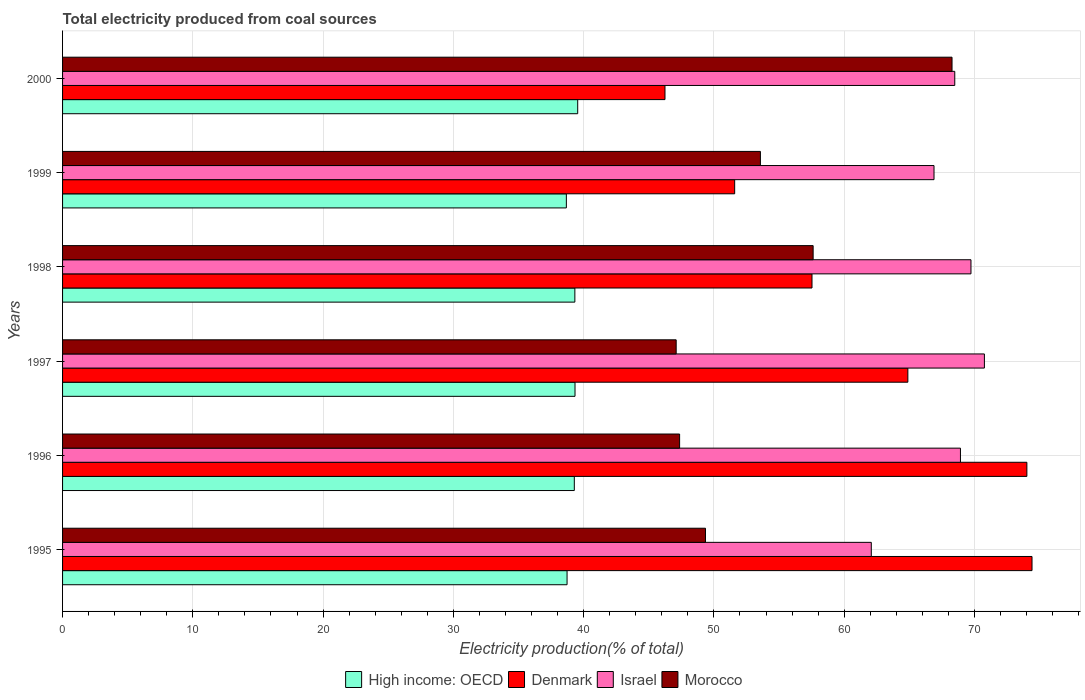How many different coloured bars are there?
Your response must be concise. 4. How many groups of bars are there?
Keep it short and to the point. 6. Are the number of bars per tick equal to the number of legend labels?
Your answer should be very brief. Yes. Are the number of bars on each tick of the Y-axis equal?
Your answer should be compact. Yes. How many bars are there on the 2nd tick from the bottom?
Keep it short and to the point. 4. What is the label of the 2nd group of bars from the top?
Provide a succinct answer. 1999. What is the total electricity produced in Denmark in 1998?
Your answer should be compact. 57.53. Across all years, what is the maximum total electricity produced in Denmark?
Provide a short and direct response. 74.42. Across all years, what is the minimum total electricity produced in Morocco?
Give a very brief answer. 47.11. What is the total total electricity produced in Morocco in the graph?
Offer a very short reply. 323.3. What is the difference between the total electricity produced in High income: OECD in 1996 and that in 1997?
Your response must be concise. -0.05. What is the difference between the total electricity produced in Denmark in 1997 and the total electricity produced in Morocco in 1998?
Keep it short and to the point. 7.27. What is the average total electricity produced in High income: OECD per year?
Provide a succinct answer. 39.15. In the year 1997, what is the difference between the total electricity produced in Denmark and total electricity produced in Morocco?
Provide a succinct answer. 17.78. What is the ratio of the total electricity produced in Israel in 1995 to that in 2000?
Provide a succinct answer. 0.91. What is the difference between the highest and the second highest total electricity produced in High income: OECD?
Your answer should be compact. 0.21. What is the difference between the highest and the lowest total electricity produced in High income: OECD?
Make the answer very short. 0.87. Is the sum of the total electricity produced in Morocco in 1997 and 1998 greater than the maximum total electricity produced in High income: OECD across all years?
Keep it short and to the point. Yes. What does the 4th bar from the top in 1997 represents?
Give a very brief answer. High income: OECD. What does the 3rd bar from the bottom in 1996 represents?
Ensure brevity in your answer.  Israel. Is it the case that in every year, the sum of the total electricity produced in Morocco and total electricity produced in Israel is greater than the total electricity produced in High income: OECD?
Provide a succinct answer. Yes. Are all the bars in the graph horizontal?
Your answer should be very brief. Yes. How many years are there in the graph?
Offer a very short reply. 6. What is the difference between two consecutive major ticks on the X-axis?
Your answer should be very brief. 10. Does the graph contain any zero values?
Your answer should be very brief. No. Where does the legend appear in the graph?
Offer a terse response. Bottom center. How are the legend labels stacked?
Your answer should be very brief. Horizontal. What is the title of the graph?
Offer a terse response. Total electricity produced from coal sources. What is the label or title of the Y-axis?
Keep it short and to the point. Years. What is the Electricity production(% of total) in High income: OECD in 1995?
Offer a very short reply. 38.73. What is the Electricity production(% of total) of Denmark in 1995?
Provide a short and direct response. 74.42. What is the Electricity production(% of total) in Israel in 1995?
Keep it short and to the point. 62.08. What is the Electricity production(% of total) of Morocco in 1995?
Offer a very short reply. 49.35. What is the Electricity production(% of total) in High income: OECD in 1996?
Your response must be concise. 39.28. What is the Electricity production(% of total) of Denmark in 1996?
Offer a very short reply. 74.03. What is the Electricity production(% of total) of Israel in 1996?
Ensure brevity in your answer.  68.93. What is the Electricity production(% of total) in Morocco in 1996?
Your response must be concise. 47.37. What is the Electricity production(% of total) in High income: OECD in 1997?
Your answer should be very brief. 39.34. What is the Electricity production(% of total) in Denmark in 1997?
Your answer should be compact. 64.89. What is the Electricity production(% of total) in Israel in 1997?
Provide a succinct answer. 70.77. What is the Electricity production(% of total) of Morocco in 1997?
Ensure brevity in your answer.  47.11. What is the Electricity production(% of total) in High income: OECD in 1998?
Ensure brevity in your answer.  39.33. What is the Electricity production(% of total) in Denmark in 1998?
Your answer should be very brief. 57.53. What is the Electricity production(% of total) in Israel in 1998?
Offer a very short reply. 69.74. What is the Electricity production(% of total) of Morocco in 1998?
Make the answer very short. 57.62. What is the Electricity production(% of total) of High income: OECD in 1999?
Give a very brief answer. 38.67. What is the Electricity production(% of total) in Denmark in 1999?
Your response must be concise. 51.6. What is the Electricity production(% of total) of Israel in 1999?
Your answer should be very brief. 66.9. What is the Electricity production(% of total) in Morocco in 1999?
Give a very brief answer. 53.57. What is the Electricity production(% of total) in High income: OECD in 2000?
Give a very brief answer. 39.55. What is the Electricity production(% of total) in Denmark in 2000?
Offer a very short reply. 46.25. What is the Electricity production(% of total) of Israel in 2000?
Keep it short and to the point. 68.49. What is the Electricity production(% of total) of Morocco in 2000?
Make the answer very short. 68.28. Across all years, what is the maximum Electricity production(% of total) in High income: OECD?
Ensure brevity in your answer.  39.55. Across all years, what is the maximum Electricity production(% of total) of Denmark?
Ensure brevity in your answer.  74.42. Across all years, what is the maximum Electricity production(% of total) of Israel?
Your response must be concise. 70.77. Across all years, what is the maximum Electricity production(% of total) of Morocco?
Your answer should be very brief. 68.28. Across all years, what is the minimum Electricity production(% of total) in High income: OECD?
Give a very brief answer. 38.67. Across all years, what is the minimum Electricity production(% of total) of Denmark?
Give a very brief answer. 46.25. Across all years, what is the minimum Electricity production(% of total) in Israel?
Provide a succinct answer. 62.08. Across all years, what is the minimum Electricity production(% of total) in Morocco?
Your answer should be compact. 47.11. What is the total Electricity production(% of total) in High income: OECD in the graph?
Your answer should be very brief. 234.9. What is the total Electricity production(% of total) of Denmark in the graph?
Offer a very short reply. 368.71. What is the total Electricity production(% of total) of Israel in the graph?
Your response must be concise. 406.9. What is the total Electricity production(% of total) of Morocco in the graph?
Your answer should be very brief. 323.3. What is the difference between the Electricity production(% of total) of High income: OECD in 1995 and that in 1996?
Provide a succinct answer. -0.56. What is the difference between the Electricity production(% of total) of Denmark in 1995 and that in 1996?
Offer a terse response. 0.4. What is the difference between the Electricity production(% of total) of Israel in 1995 and that in 1996?
Give a very brief answer. -6.84. What is the difference between the Electricity production(% of total) in Morocco in 1995 and that in 1996?
Keep it short and to the point. 1.99. What is the difference between the Electricity production(% of total) in High income: OECD in 1995 and that in 1997?
Offer a very short reply. -0.61. What is the difference between the Electricity production(% of total) of Denmark in 1995 and that in 1997?
Provide a short and direct response. 9.53. What is the difference between the Electricity production(% of total) in Israel in 1995 and that in 1997?
Your answer should be compact. -8.68. What is the difference between the Electricity production(% of total) of Morocco in 1995 and that in 1997?
Provide a short and direct response. 2.25. What is the difference between the Electricity production(% of total) of High income: OECD in 1995 and that in 1998?
Offer a terse response. -0.6. What is the difference between the Electricity production(% of total) of Denmark in 1995 and that in 1998?
Your answer should be compact. 16.89. What is the difference between the Electricity production(% of total) of Israel in 1995 and that in 1998?
Provide a succinct answer. -7.65. What is the difference between the Electricity production(% of total) in Morocco in 1995 and that in 1998?
Provide a short and direct response. -8.26. What is the difference between the Electricity production(% of total) in High income: OECD in 1995 and that in 1999?
Offer a very short reply. 0.05. What is the difference between the Electricity production(% of total) in Denmark in 1995 and that in 1999?
Your response must be concise. 22.83. What is the difference between the Electricity production(% of total) of Israel in 1995 and that in 1999?
Ensure brevity in your answer.  -4.81. What is the difference between the Electricity production(% of total) in Morocco in 1995 and that in 1999?
Offer a very short reply. -4.22. What is the difference between the Electricity production(% of total) of High income: OECD in 1995 and that in 2000?
Make the answer very short. -0.82. What is the difference between the Electricity production(% of total) in Denmark in 1995 and that in 2000?
Provide a succinct answer. 28.18. What is the difference between the Electricity production(% of total) of Israel in 1995 and that in 2000?
Your answer should be very brief. -6.41. What is the difference between the Electricity production(% of total) of Morocco in 1995 and that in 2000?
Your answer should be compact. -18.93. What is the difference between the Electricity production(% of total) of High income: OECD in 1996 and that in 1997?
Make the answer very short. -0.05. What is the difference between the Electricity production(% of total) in Denmark in 1996 and that in 1997?
Your answer should be very brief. 9.14. What is the difference between the Electricity production(% of total) of Israel in 1996 and that in 1997?
Provide a short and direct response. -1.84. What is the difference between the Electricity production(% of total) in Morocco in 1996 and that in 1997?
Your response must be concise. 0.26. What is the difference between the Electricity production(% of total) of High income: OECD in 1996 and that in 1998?
Ensure brevity in your answer.  -0.04. What is the difference between the Electricity production(% of total) in Denmark in 1996 and that in 1998?
Offer a very short reply. 16.5. What is the difference between the Electricity production(% of total) of Israel in 1996 and that in 1998?
Your response must be concise. -0.81. What is the difference between the Electricity production(% of total) of Morocco in 1996 and that in 1998?
Your response must be concise. -10.25. What is the difference between the Electricity production(% of total) in High income: OECD in 1996 and that in 1999?
Give a very brief answer. 0.61. What is the difference between the Electricity production(% of total) in Denmark in 1996 and that in 1999?
Offer a very short reply. 22.43. What is the difference between the Electricity production(% of total) in Israel in 1996 and that in 1999?
Your answer should be very brief. 2.03. What is the difference between the Electricity production(% of total) in Morocco in 1996 and that in 1999?
Offer a very short reply. -6.2. What is the difference between the Electricity production(% of total) of High income: OECD in 1996 and that in 2000?
Offer a terse response. -0.26. What is the difference between the Electricity production(% of total) in Denmark in 1996 and that in 2000?
Your response must be concise. 27.78. What is the difference between the Electricity production(% of total) in Israel in 1996 and that in 2000?
Offer a terse response. 0.44. What is the difference between the Electricity production(% of total) in Morocco in 1996 and that in 2000?
Your response must be concise. -20.91. What is the difference between the Electricity production(% of total) of High income: OECD in 1997 and that in 1998?
Make the answer very short. 0.01. What is the difference between the Electricity production(% of total) in Denmark in 1997 and that in 1998?
Offer a very short reply. 7.36. What is the difference between the Electricity production(% of total) of Israel in 1997 and that in 1998?
Give a very brief answer. 1.03. What is the difference between the Electricity production(% of total) in Morocco in 1997 and that in 1998?
Your answer should be very brief. -10.51. What is the difference between the Electricity production(% of total) of High income: OECD in 1997 and that in 1999?
Provide a short and direct response. 0.67. What is the difference between the Electricity production(% of total) in Denmark in 1997 and that in 1999?
Your answer should be compact. 13.29. What is the difference between the Electricity production(% of total) in Israel in 1997 and that in 1999?
Give a very brief answer. 3.87. What is the difference between the Electricity production(% of total) in Morocco in 1997 and that in 1999?
Provide a succinct answer. -6.47. What is the difference between the Electricity production(% of total) in High income: OECD in 1997 and that in 2000?
Your response must be concise. -0.21. What is the difference between the Electricity production(% of total) in Denmark in 1997 and that in 2000?
Provide a short and direct response. 18.64. What is the difference between the Electricity production(% of total) in Israel in 1997 and that in 2000?
Your response must be concise. 2.28. What is the difference between the Electricity production(% of total) of Morocco in 1997 and that in 2000?
Your response must be concise. -21.18. What is the difference between the Electricity production(% of total) of High income: OECD in 1998 and that in 1999?
Your answer should be compact. 0.65. What is the difference between the Electricity production(% of total) of Denmark in 1998 and that in 1999?
Your answer should be compact. 5.94. What is the difference between the Electricity production(% of total) in Israel in 1998 and that in 1999?
Give a very brief answer. 2.84. What is the difference between the Electricity production(% of total) of Morocco in 1998 and that in 1999?
Your answer should be compact. 4.05. What is the difference between the Electricity production(% of total) of High income: OECD in 1998 and that in 2000?
Offer a terse response. -0.22. What is the difference between the Electricity production(% of total) of Denmark in 1998 and that in 2000?
Keep it short and to the point. 11.29. What is the difference between the Electricity production(% of total) in Israel in 1998 and that in 2000?
Make the answer very short. 1.24. What is the difference between the Electricity production(% of total) of Morocco in 1998 and that in 2000?
Make the answer very short. -10.66. What is the difference between the Electricity production(% of total) of High income: OECD in 1999 and that in 2000?
Provide a succinct answer. -0.87. What is the difference between the Electricity production(% of total) in Denmark in 1999 and that in 2000?
Provide a succinct answer. 5.35. What is the difference between the Electricity production(% of total) of Israel in 1999 and that in 2000?
Offer a terse response. -1.59. What is the difference between the Electricity production(% of total) in Morocco in 1999 and that in 2000?
Offer a very short reply. -14.71. What is the difference between the Electricity production(% of total) of High income: OECD in 1995 and the Electricity production(% of total) of Denmark in 1996?
Give a very brief answer. -35.3. What is the difference between the Electricity production(% of total) in High income: OECD in 1995 and the Electricity production(% of total) in Israel in 1996?
Provide a succinct answer. -30.2. What is the difference between the Electricity production(% of total) of High income: OECD in 1995 and the Electricity production(% of total) of Morocco in 1996?
Keep it short and to the point. -8.64. What is the difference between the Electricity production(% of total) of Denmark in 1995 and the Electricity production(% of total) of Israel in 1996?
Provide a succinct answer. 5.49. What is the difference between the Electricity production(% of total) of Denmark in 1995 and the Electricity production(% of total) of Morocco in 1996?
Provide a short and direct response. 27.05. What is the difference between the Electricity production(% of total) of Israel in 1995 and the Electricity production(% of total) of Morocco in 1996?
Your answer should be compact. 14.72. What is the difference between the Electricity production(% of total) in High income: OECD in 1995 and the Electricity production(% of total) in Denmark in 1997?
Your answer should be very brief. -26.16. What is the difference between the Electricity production(% of total) in High income: OECD in 1995 and the Electricity production(% of total) in Israel in 1997?
Provide a short and direct response. -32.04. What is the difference between the Electricity production(% of total) in High income: OECD in 1995 and the Electricity production(% of total) in Morocco in 1997?
Offer a terse response. -8.38. What is the difference between the Electricity production(% of total) in Denmark in 1995 and the Electricity production(% of total) in Israel in 1997?
Offer a terse response. 3.66. What is the difference between the Electricity production(% of total) of Denmark in 1995 and the Electricity production(% of total) of Morocco in 1997?
Give a very brief answer. 27.32. What is the difference between the Electricity production(% of total) in Israel in 1995 and the Electricity production(% of total) in Morocco in 1997?
Provide a succinct answer. 14.98. What is the difference between the Electricity production(% of total) in High income: OECD in 1995 and the Electricity production(% of total) in Denmark in 1998?
Your answer should be compact. -18.8. What is the difference between the Electricity production(% of total) in High income: OECD in 1995 and the Electricity production(% of total) in Israel in 1998?
Offer a terse response. -31.01. What is the difference between the Electricity production(% of total) in High income: OECD in 1995 and the Electricity production(% of total) in Morocco in 1998?
Offer a very short reply. -18.89. What is the difference between the Electricity production(% of total) in Denmark in 1995 and the Electricity production(% of total) in Israel in 1998?
Give a very brief answer. 4.69. What is the difference between the Electricity production(% of total) of Denmark in 1995 and the Electricity production(% of total) of Morocco in 1998?
Your response must be concise. 16.8. What is the difference between the Electricity production(% of total) of Israel in 1995 and the Electricity production(% of total) of Morocco in 1998?
Your response must be concise. 4.47. What is the difference between the Electricity production(% of total) of High income: OECD in 1995 and the Electricity production(% of total) of Denmark in 1999?
Give a very brief answer. -12.87. What is the difference between the Electricity production(% of total) in High income: OECD in 1995 and the Electricity production(% of total) in Israel in 1999?
Your answer should be compact. -28.17. What is the difference between the Electricity production(% of total) in High income: OECD in 1995 and the Electricity production(% of total) in Morocco in 1999?
Give a very brief answer. -14.84. What is the difference between the Electricity production(% of total) in Denmark in 1995 and the Electricity production(% of total) in Israel in 1999?
Make the answer very short. 7.52. What is the difference between the Electricity production(% of total) of Denmark in 1995 and the Electricity production(% of total) of Morocco in 1999?
Offer a terse response. 20.85. What is the difference between the Electricity production(% of total) in Israel in 1995 and the Electricity production(% of total) in Morocco in 1999?
Give a very brief answer. 8.51. What is the difference between the Electricity production(% of total) in High income: OECD in 1995 and the Electricity production(% of total) in Denmark in 2000?
Give a very brief answer. -7.52. What is the difference between the Electricity production(% of total) of High income: OECD in 1995 and the Electricity production(% of total) of Israel in 2000?
Provide a succinct answer. -29.76. What is the difference between the Electricity production(% of total) in High income: OECD in 1995 and the Electricity production(% of total) in Morocco in 2000?
Your answer should be compact. -29.55. What is the difference between the Electricity production(% of total) in Denmark in 1995 and the Electricity production(% of total) in Israel in 2000?
Keep it short and to the point. 5.93. What is the difference between the Electricity production(% of total) in Denmark in 1995 and the Electricity production(% of total) in Morocco in 2000?
Your response must be concise. 6.14. What is the difference between the Electricity production(% of total) in Israel in 1995 and the Electricity production(% of total) in Morocco in 2000?
Provide a short and direct response. -6.2. What is the difference between the Electricity production(% of total) in High income: OECD in 1996 and the Electricity production(% of total) in Denmark in 1997?
Provide a succinct answer. -25.61. What is the difference between the Electricity production(% of total) of High income: OECD in 1996 and the Electricity production(% of total) of Israel in 1997?
Keep it short and to the point. -31.48. What is the difference between the Electricity production(% of total) of High income: OECD in 1996 and the Electricity production(% of total) of Morocco in 1997?
Give a very brief answer. -7.82. What is the difference between the Electricity production(% of total) in Denmark in 1996 and the Electricity production(% of total) in Israel in 1997?
Provide a short and direct response. 3.26. What is the difference between the Electricity production(% of total) of Denmark in 1996 and the Electricity production(% of total) of Morocco in 1997?
Offer a terse response. 26.92. What is the difference between the Electricity production(% of total) of Israel in 1996 and the Electricity production(% of total) of Morocco in 1997?
Provide a short and direct response. 21.82. What is the difference between the Electricity production(% of total) of High income: OECD in 1996 and the Electricity production(% of total) of Denmark in 1998?
Ensure brevity in your answer.  -18.25. What is the difference between the Electricity production(% of total) in High income: OECD in 1996 and the Electricity production(% of total) in Israel in 1998?
Provide a short and direct response. -30.45. What is the difference between the Electricity production(% of total) in High income: OECD in 1996 and the Electricity production(% of total) in Morocco in 1998?
Give a very brief answer. -18.33. What is the difference between the Electricity production(% of total) of Denmark in 1996 and the Electricity production(% of total) of Israel in 1998?
Provide a short and direct response. 4.29. What is the difference between the Electricity production(% of total) of Denmark in 1996 and the Electricity production(% of total) of Morocco in 1998?
Make the answer very short. 16.41. What is the difference between the Electricity production(% of total) of Israel in 1996 and the Electricity production(% of total) of Morocco in 1998?
Provide a succinct answer. 11.31. What is the difference between the Electricity production(% of total) in High income: OECD in 1996 and the Electricity production(% of total) in Denmark in 1999?
Your response must be concise. -12.31. What is the difference between the Electricity production(% of total) of High income: OECD in 1996 and the Electricity production(% of total) of Israel in 1999?
Your answer should be very brief. -27.61. What is the difference between the Electricity production(% of total) in High income: OECD in 1996 and the Electricity production(% of total) in Morocco in 1999?
Give a very brief answer. -14.29. What is the difference between the Electricity production(% of total) of Denmark in 1996 and the Electricity production(% of total) of Israel in 1999?
Make the answer very short. 7.13. What is the difference between the Electricity production(% of total) of Denmark in 1996 and the Electricity production(% of total) of Morocco in 1999?
Provide a short and direct response. 20.46. What is the difference between the Electricity production(% of total) in Israel in 1996 and the Electricity production(% of total) in Morocco in 1999?
Offer a terse response. 15.36. What is the difference between the Electricity production(% of total) of High income: OECD in 1996 and the Electricity production(% of total) of Denmark in 2000?
Give a very brief answer. -6.96. What is the difference between the Electricity production(% of total) of High income: OECD in 1996 and the Electricity production(% of total) of Israel in 2000?
Provide a short and direct response. -29.21. What is the difference between the Electricity production(% of total) of High income: OECD in 1996 and the Electricity production(% of total) of Morocco in 2000?
Give a very brief answer. -29. What is the difference between the Electricity production(% of total) of Denmark in 1996 and the Electricity production(% of total) of Israel in 2000?
Give a very brief answer. 5.54. What is the difference between the Electricity production(% of total) in Denmark in 1996 and the Electricity production(% of total) in Morocco in 2000?
Your answer should be compact. 5.75. What is the difference between the Electricity production(% of total) in Israel in 1996 and the Electricity production(% of total) in Morocco in 2000?
Your answer should be very brief. 0.65. What is the difference between the Electricity production(% of total) of High income: OECD in 1997 and the Electricity production(% of total) of Denmark in 1998?
Your answer should be very brief. -18.19. What is the difference between the Electricity production(% of total) in High income: OECD in 1997 and the Electricity production(% of total) in Israel in 1998?
Your answer should be very brief. -30.4. What is the difference between the Electricity production(% of total) of High income: OECD in 1997 and the Electricity production(% of total) of Morocco in 1998?
Keep it short and to the point. -18.28. What is the difference between the Electricity production(% of total) in Denmark in 1997 and the Electricity production(% of total) in Israel in 1998?
Make the answer very short. -4.85. What is the difference between the Electricity production(% of total) in Denmark in 1997 and the Electricity production(% of total) in Morocco in 1998?
Offer a terse response. 7.27. What is the difference between the Electricity production(% of total) of Israel in 1997 and the Electricity production(% of total) of Morocco in 1998?
Your answer should be compact. 13.15. What is the difference between the Electricity production(% of total) of High income: OECD in 1997 and the Electricity production(% of total) of Denmark in 1999?
Make the answer very short. -12.26. What is the difference between the Electricity production(% of total) of High income: OECD in 1997 and the Electricity production(% of total) of Israel in 1999?
Give a very brief answer. -27.56. What is the difference between the Electricity production(% of total) of High income: OECD in 1997 and the Electricity production(% of total) of Morocco in 1999?
Keep it short and to the point. -14.23. What is the difference between the Electricity production(% of total) of Denmark in 1997 and the Electricity production(% of total) of Israel in 1999?
Make the answer very short. -2.01. What is the difference between the Electricity production(% of total) of Denmark in 1997 and the Electricity production(% of total) of Morocco in 1999?
Offer a very short reply. 11.32. What is the difference between the Electricity production(% of total) in Israel in 1997 and the Electricity production(% of total) in Morocco in 1999?
Your answer should be very brief. 17.2. What is the difference between the Electricity production(% of total) in High income: OECD in 1997 and the Electricity production(% of total) in Denmark in 2000?
Provide a short and direct response. -6.91. What is the difference between the Electricity production(% of total) of High income: OECD in 1997 and the Electricity production(% of total) of Israel in 2000?
Your answer should be very brief. -29.15. What is the difference between the Electricity production(% of total) in High income: OECD in 1997 and the Electricity production(% of total) in Morocco in 2000?
Provide a succinct answer. -28.94. What is the difference between the Electricity production(% of total) of Denmark in 1997 and the Electricity production(% of total) of Israel in 2000?
Provide a short and direct response. -3.6. What is the difference between the Electricity production(% of total) in Denmark in 1997 and the Electricity production(% of total) in Morocco in 2000?
Your answer should be very brief. -3.39. What is the difference between the Electricity production(% of total) of Israel in 1997 and the Electricity production(% of total) of Morocco in 2000?
Offer a terse response. 2.49. What is the difference between the Electricity production(% of total) in High income: OECD in 1998 and the Electricity production(% of total) in Denmark in 1999?
Provide a succinct answer. -12.27. What is the difference between the Electricity production(% of total) of High income: OECD in 1998 and the Electricity production(% of total) of Israel in 1999?
Your answer should be very brief. -27.57. What is the difference between the Electricity production(% of total) of High income: OECD in 1998 and the Electricity production(% of total) of Morocco in 1999?
Keep it short and to the point. -14.24. What is the difference between the Electricity production(% of total) of Denmark in 1998 and the Electricity production(% of total) of Israel in 1999?
Give a very brief answer. -9.37. What is the difference between the Electricity production(% of total) in Denmark in 1998 and the Electricity production(% of total) in Morocco in 1999?
Keep it short and to the point. 3.96. What is the difference between the Electricity production(% of total) in Israel in 1998 and the Electricity production(% of total) in Morocco in 1999?
Your answer should be compact. 16.16. What is the difference between the Electricity production(% of total) of High income: OECD in 1998 and the Electricity production(% of total) of Denmark in 2000?
Keep it short and to the point. -6.92. What is the difference between the Electricity production(% of total) in High income: OECD in 1998 and the Electricity production(% of total) in Israel in 2000?
Give a very brief answer. -29.16. What is the difference between the Electricity production(% of total) in High income: OECD in 1998 and the Electricity production(% of total) in Morocco in 2000?
Keep it short and to the point. -28.95. What is the difference between the Electricity production(% of total) in Denmark in 1998 and the Electricity production(% of total) in Israel in 2000?
Give a very brief answer. -10.96. What is the difference between the Electricity production(% of total) of Denmark in 1998 and the Electricity production(% of total) of Morocco in 2000?
Give a very brief answer. -10.75. What is the difference between the Electricity production(% of total) in Israel in 1998 and the Electricity production(% of total) in Morocco in 2000?
Keep it short and to the point. 1.45. What is the difference between the Electricity production(% of total) of High income: OECD in 1999 and the Electricity production(% of total) of Denmark in 2000?
Provide a short and direct response. -7.57. What is the difference between the Electricity production(% of total) of High income: OECD in 1999 and the Electricity production(% of total) of Israel in 2000?
Give a very brief answer. -29.82. What is the difference between the Electricity production(% of total) in High income: OECD in 1999 and the Electricity production(% of total) in Morocco in 2000?
Keep it short and to the point. -29.61. What is the difference between the Electricity production(% of total) of Denmark in 1999 and the Electricity production(% of total) of Israel in 2000?
Provide a succinct answer. -16.9. What is the difference between the Electricity production(% of total) in Denmark in 1999 and the Electricity production(% of total) in Morocco in 2000?
Make the answer very short. -16.69. What is the difference between the Electricity production(% of total) of Israel in 1999 and the Electricity production(% of total) of Morocco in 2000?
Make the answer very short. -1.38. What is the average Electricity production(% of total) of High income: OECD per year?
Offer a very short reply. 39.15. What is the average Electricity production(% of total) of Denmark per year?
Ensure brevity in your answer.  61.45. What is the average Electricity production(% of total) in Israel per year?
Offer a very short reply. 67.82. What is the average Electricity production(% of total) of Morocco per year?
Your answer should be very brief. 53.88. In the year 1995, what is the difference between the Electricity production(% of total) of High income: OECD and Electricity production(% of total) of Denmark?
Give a very brief answer. -35.69. In the year 1995, what is the difference between the Electricity production(% of total) of High income: OECD and Electricity production(% of total) of Israel?
Your response must be concise. -23.35. In the year 1995, what is the difference between the Electricity production(% of total) in High income: OECD and Electricity production(% of total) in Morocco?
Ensure brevity in your answer.  -10.63. In the year 1995, what is the difference between the Electricity production(% of total) of Denmark and Electricity production(% of total) of Israel?
Keep it short and to the point. 12.34. In the year 1995, what is the difference between the Electricity production(% of total) of Denmark and Electricity production(% of total) of Morocco?
Your answer should be compact. 25.07. In the year 1995, what is the difference between the Electricity production(% of total) of Israel and Electricity production(% of total) of Morocco?
Your answer should be very brief. 12.73. In the year 1996, what is the difference between the Electricity production(% of total) of High income: OECD and Electricity production(% of total) of Denmark?
Give a very brief answer. -34.74. In the year 1996, what is the difference between the Electricity production(% of total) of High income: OECD and Electricity production(% of total) of Israel?
Provide a short and direct response. -29.64. In the year 1996, what is the difference between the Electricity production(% of total) of High income: OECD and Electricity production(% of total) of Morocco?
Your answer should be very brief. -8.08. In the year 1996, what is the difference between the Electricity production(% of total) of Denmark and Electricity production(% of total) of Israel?
Offer a very short reply. 5.1. In the year 1996, what is the difference between the Electricity production(% of total) of Denmark and Electricity production(% of total) of Morocco?
Your response must be concise. 26.66. In the year 1996, what is the difference between the Electricity production(% of total) in Israel and Electricity production(% of total) in Morocco?
Provide a short and direct response. 21.56. In the year 1997, what is the difference between the Electricity production(% of total) of High income: OECD and Electricity production(% of total) of Denmark?
Keep it short and to the point. -25.55. In the year 1997, what is the difference between the Electricity production(% of total) of High income: OECD and Electricity production(% of total) of Israel?
Offer a terse response. -31.43. In the year 1997, what is the difference between the Electricity production(% of total) in High income: OECD and Electricity production(% of total) in Morocco?
Give a very brief answer. -7.77. In the year 1997, what is the difference between the Electricity production(% of total) of Denmark and Electricity production(% of total) of Israel?
Your response must be concise. -5.88. In the year 1997, what is the difference between the Electricity production(% of total) of Denmark and Electricity production(% of total) of Morocco?
Your answer should be very brief. 17.78. In the year 1997, what is the difference between the Electricity production(% of total) in Israel and Electricity production(% of total) in Morocco?
Your answer should be compact. 23.66. In the year 1998, what is the difference between the Electricity production(% of total) in High income: OECD and Electricity production(% of total) in Denmark?
Offer a terse response. -18.2. In the year 1998, what is the difference between the Electricity production(% of total) of High income: OECD and Electricity production(% of total) of Israel?
Give a very brief answer. -30.41. In the year 1998, what is the difference between the Electricity production(% of total) of High income: OECD and Electricity production(% of total) of Morocco?
Your answer should be very brief. -18.29. In the year 1998, what is the difference between the Electricity production(% of total) in Denmark and Electricity production(% of total) in Israel?
Offer a terse response. -12.2. In the year 1998, what is the difference between the Electricity production(% of total) of Denmark and Electricity production(% of total) of Morocco?
Provide a succinct answer. -0.09. In the year 1998, what is the difference between the Electricity production(% of total) of Israel and Electricity production(% of total) of Morocco?
Keep it short and to the point. 12.12. In the year 1999, what is the difference between the Electricity production(% of total) of High income: OECD and Electricity production(% of total) of Denmark?
Provide a succinct answer. -12.92. In the year 1999, what is the difference between the Electricity production(% of total) in High income: OECD and Electricity production(% of total) in Israel?
Make the answer very short. -28.22. In the year 1999, what is the difference between the Electricity production(% of total) of High income: OECD and Electricity production(% of total) of Morocco?
Offer a very short reply. -14.9. In the year 1999, what is the difference between the Electricity production(% of total) of Denmark and Electricity production(% of total) of Israel?
Ensure brevity in your answer.  -15.3. In the year 1999, what is the difference between the Electricity production(% of total) in Denmark and Electricity production(% of total) in Morocco?
Give a very brief answer. -1.98. In the year 1999, what is the difference between the Electricity production(% of total) of Israel and Electricity production(% of total) of Morocco?
Your answer should be very brief. 13.33. In the year 2000, what is the difference between the Electricity production(% of total) in High income: OECD and Electricity production(% of total) in Denmark?
Keep it short and to the point. -6.7. In the year 2000, what is the difference between the Electricity production(% of total) of High income: OECD and Electricity production(% of total) of Israel?
Offer a very short reply. -28.95. In the year 2000, what is the difference between the Electricity production(% of total) in High income: OECD and Electricity production(% of total) in Morocco?
Offer a terse response. -28.74. In the year 2000, what is the difference between the Electricity production(% of total) in Denmark and Electricity production(% of total) in Israel?
Make the answer very short. -22.25. In the year 2000, what is the difference between the Electricity production(% of total) of Denmark and Electricity production(% of total) of Morocco?
Offer a terse response. -22.04. In the year 2000, what is the difference between the Electricity production(% of total) of Israel and Electricity production(% of total) of Morocco?
Offer a very short reply. 0.21. What is the ratio of the Electricity production(% of total) of High income: OECD in 1995 to that in 1996?
Offer a very short reply. 0.99. What is the ratio of the Electricity production(% of total) in Denmark in 1995 to that in 1996?
Your answer should be very brief. 1.01. What is the ratio of the Electricity production(% of total) in Israel in 1995 to that in 1996?
Provide a short and direct response. 0.9. What is the ratio of the Electricity production(% of total) of Morocco in 1995 to that in 1996?
Provide a succinct answer. 1.04. What is the ratio of the Electricity production(% of total) in High income: OECD in 1995 to that in 1997?
Provide a succinct answer. 0.98. What is the ratio of the Electricity production(% of total) in Denmark in 1995 to that in 1997?
Provide a succinct answer. 1.15. What is the ratio of the Electricity production(% of total) in Israel in 1995 to that in 1997?
Provide a short and direct response. 0.88. What is the ratio of the Electricity production(% of total) in Morocco in 1995 to that in 1997?
Provide a succinct answer. 1.05. What is the ratio of the Electricity production(% of total) in High income: OECD in 1995 to that in 1998?
Make the answer very short. 0.98. What is the ratio of the Electricity production(% of total) of Denmark in 1995 to that in 1998?
Provide a succinct answer. 1.29. What is the ratio of the Electricity production(% of total) of Israel in 1995 to that in 1998?
Keep it short and to the point. 0.89. What is the ratio of the Electricity production(% of total) in Morocco in 1995 to that in 1998?
Provide a succinct answer. 0.86. What is the ratio of the Electricity production(% of total) of High income: OECD in 1995 to that in 1999?
Your answer should be very brief. 1. What is the ratio of the Electricity production(% of total) of Denmark in 1995 to that in 1999?
Keep it short and to the point. 1.44. What is the ratio of the Electricity production(% of total) in Israel in 1995 to that in 1999?
Provide a succinct answer. 0.93. What is the ratio of the Electricity production(% of total) in Morocco in 1995 to that in 1999?
Give a very brief answer. 0.92. What is the ratio of the Electricity production(% of total) of High income: OECD in 1995 to that in 2000?
Offer a very short reply. 0.98. What is the ratio of the Electricity production(% of total) in Denmark in 1995 to that in 2000?
Provide a succinct answer. 1.61. What is the ratio of the Electricity production(% of total) in Israel in 1995 to that in 2000?
Ensure brevity in your answer.  0.91. What is the ratio of the Electricity production(% of total) of Morocco in 1995 to that in 2000?
Your answer should be compact. 0.72. What is the ratio of the Electricity production(% of total) of High income: OECD in 1996 to that in 1997?
Your answer should be compact. 1. What is the ratio of the Electricity production(% of total) of Denmark in 1996 to that in 1997?
Ensure brevity in your answer.  1.14. What is the ratio of the Electricity production(% of total) of Israel in 1996 to that in 1997?
Ensure brevity in your answer.  0.97. What is the ratio of the Electricity production(% of total) in Morocco in 1996 to that in 1997?
Give a very brief answer. 1.01. What is the ratio of the Electricity production(% of total) of Denmark in 1996 to that in 1998?
Give a very brief answer. 1.29. What is the ratio of the Electricity production(% of total) in Israel in 1996 to that in 1998?
Ensure brevity in your answer.  0.99. What is the ratio of the Electricity production(% of total) of Morocco in 1996 to that in 1998?
Provide a short and direct response. 0.82. What is the ratio of the Electricity production(% of total) of High income: OECD in 1996 to that in 1999?
Your answer should be very brief. 1.02. What is the ratio of the Electricity production(% of total) in Denmark in 1996 to that in 1999?
Make the answer very short. 1.43. What is the ratio of the Electricity production(% of total) in Israel in 1996 to that in 1999?
Your answer should be compact. 1.03. What is the ratio of the Electricity production(% of total) of Morocco in 1996 to that in 1999?
Offer a very short reply. 0.88. What is the ratio of the Electricity production(% of total) of High income: OECD in 1996 to that in 2000?
Provide a succinct answer. 0.99. What is the ratio of the Electricity production(% of total) in Denmark in 1996 to that in 2000?
Ensure brevity in your answer.  1.6. What is the ratio of the Electricity production(% of total) of Israel in 1996 to that in 2000?
Offer a terse response. 1.01. What is the ratio of the Electricity production(% of total) in Morocco in 1996 to that in 2000?
Keep it short and to the point. 0.69. What is the ratio of the Electricity production(% of total) of Denmark in 1997 to that in 1998?
Provide a short and direct response. 1.13. What is the ratio of the Electricity production(% of total) of Israel in 1997 to that in 1998?
Your answer should be very brief. 1.01. What is the ratio of the Electricity production(% of total) of Morocco in 1997 to that in 1998?
Your answer should be very brief. 0.82. What is the ratio of the Electricity production(% of total) of High income: OECD in 1997 to that in 1999?
Make the answer very short. 1.02. What is the ratio of the Electricity production(% of total) in Denmark in 1997 to that in 1999?
Give a very brief answer. 1.26. What is the ratio of the Electricity production(% of total) in Israel in 1997 to that in 1999?
Offer a very short reply. 1.06. What is the ratio of the Electricity production(% of total) in Morocco in 1997 to that in 1999?
Your answer should be very brief. 0.88. What is the ratio of the Electricity production(% of total) of High income: OECD in 1997 to that in 2000?
Provide a short and direct response. 0.99. What is the ratio of the Electricity production(% of total) in Denmark in 1997 to that in 2000?
Keep it short and to the point. 1.4. What is the ratio of the Electricity production(% of total) of Israel in 1997 to that in 2000?
Your response must be concise. 1.03. What is the ratio of the Electricity production(% of total) of Morocco in 1997 to that in 2000?
Ensure brevity in your answer.  0.69. What is the ratio of the Electricity production(% of total) in High income: OECD in 1998 to that in 1999?
Your response must be concise. 1.02. What is the ratio of the Electricity production(% of total) in Denmark in 1998 to that in 1999?
Provide a short and direct response. 1.12. What is the ratio of the Electricity production(% of total) of Israel in 1998 to that in 1999?
Your answer should be very brief. 1.04. What is the ratio of the Electricity production(% of total) in Morocco in 1998 to that in 1999?
Your response must be concise. 1.08. What is the ratio of the Electricity production(% of total) in Denmark in 1998 to that in 2000?
Offer a very short reply. 1.24. What is the ratio of the Electricity production(% of total) in Israel in 1998 to that in 2000?
Provide a short and direct response. 1.02. What is the ratio of the Electricity production(% of total) of Morocco in 1998 to that in 2000?
Provide a short and direct response. 0.84. What is the ratio of the Electricity production(% of total) in High income: OECD in 1999 to that in 2000?
Offer a terse response. 0.98. What is the ratio of the Electricity production(% of total) of Denmark in 1999 to that in 2000?
Provide a short and direct response. 1.12. What is the ratio of the Electricity production(% of total) in Israel in 1999 to that in 2000?
Ensure brevity in your answer.  0.98. What is the ratio of the Electricity production(% of total) in Morocco in 1999 to that in 2000?
Your response must be concise. 0.78. What is the difference between the highest and the second highest Electricity production(% of total) in High income: OECD?
Your response must be concise. 0.21. What is the difference between the highest and the second highest Electricity production(% of total) in Denmark?
Offer a very short reply. 0.4. What is the difference between the highest and the second highest Electricity production(% of total) of Israel?
Your answer should be compact. 1.03. What is the difference between the highest and the second highest Electricity production(% of total) in Morocco?
Offer a very short reply. 10.66. What is the difference between the highest and the lowest Electricity production(% of total) of High income: OECD?
Offer a very short reply. 0.87. What is the difference between the highest and the lowest Electricity production(% of total) in Denmark?
Your answer should be compact. 28.18. What is the difference between the highest and the lowest Electricity production(% of total) in Israel?
Your answer should be very brief. 8.68. What is the difference between the highest and the lowest Electricity production(% of total) in Morocco?
Provide a short and direct response. 21.18. 